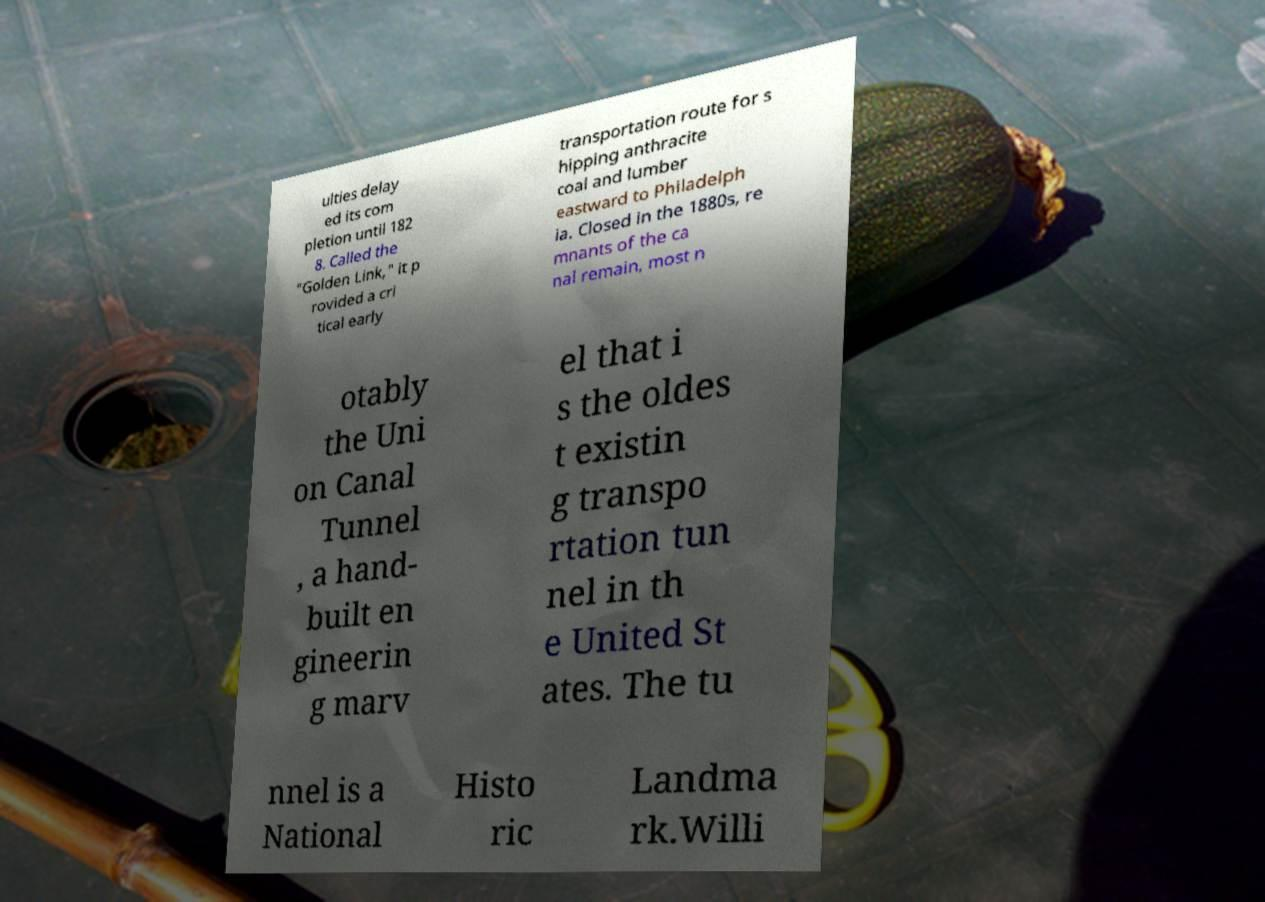Could you extract and type out the text from this image? ulties delay ed its com pletion until 182 8. Called the "Golden Link," it p rovided a cri tical early transportation route for s hipping anthracite coal and lumber eastward to Philadelph ia. Closed in the 1880s, re mnants of the ca nal remain, most n otably the Uni on Canal Tunnel , a hand- built en gineerin g marv el that i s the oldes t existin g transpo rtation tun nel in th e United St ates. The tu nnel is a National Histo ric Landma rk.Willi 